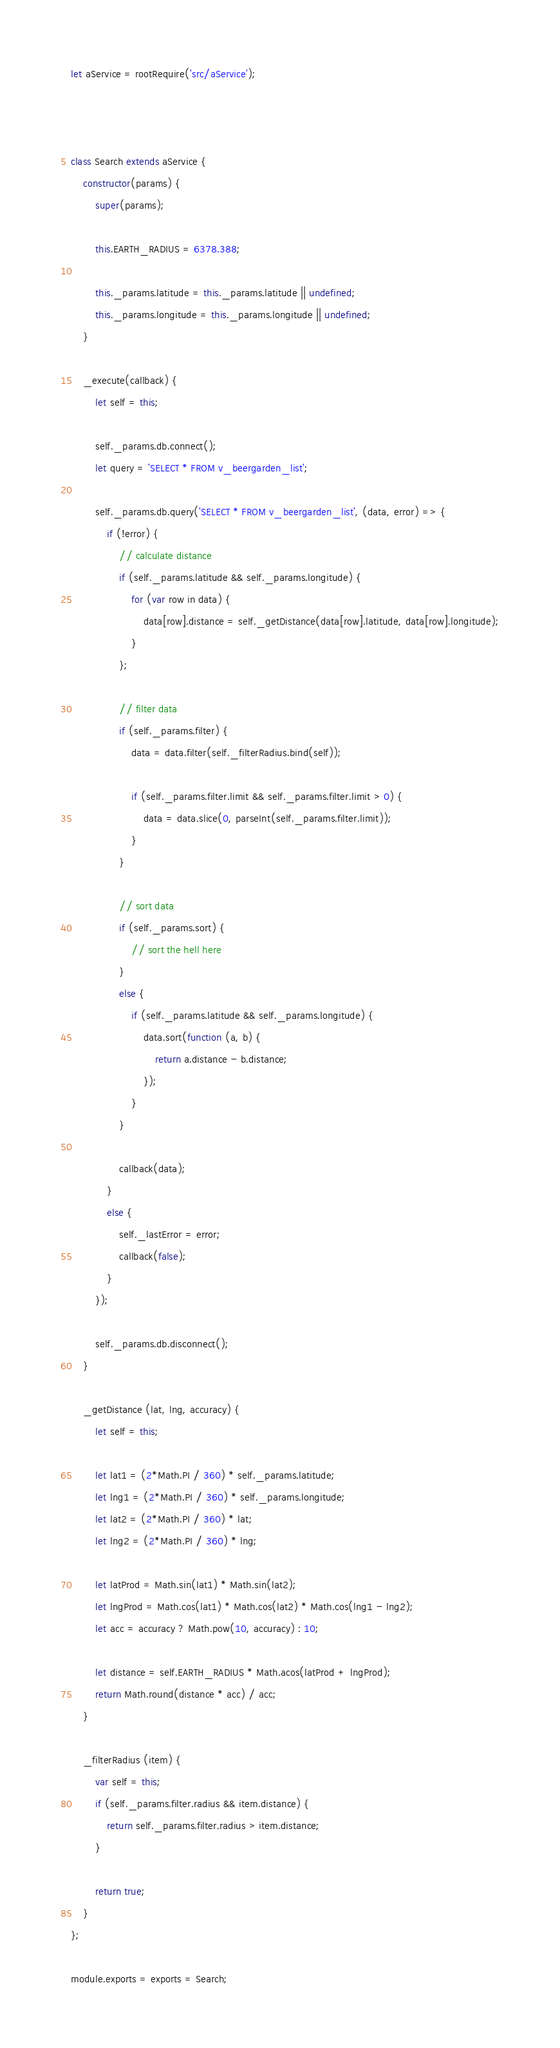Convert code to text. <code><loc_0><loc_0><loc_500><loc_500><_JavaScript_>let aService = rootRequire('src/aService');



class Search extends aService {
    constructor(params) {
        super(params);

        this.EARTH_RADIUS = 6378.388;

        this._params.latitude = this._params.latitude || undefined;
        this._params.longitude = this._params.longitude || undefined;
    }

    _execute(callback) {
        let self = this;

        self._params.db.connect();
        let query = 'SELECT * FROM v_beergarden_list';

        self._params.db.query('SELECT * FROM v_beergarden_list', (data, error) => {
            if (!error) {
                // calculate distance
                if (self._params.latitude && self._params.longitude) {
                    for (var row in data) {
                        data[row].distance = self._getDistance(data[row].latitude, data[row].longitude);
                    }
                };

                // filter data
                if (self._params.filter) {
                    data = data.filter(self._filterRadius.bind(self));

                    if (self._params.filter.limit && self._params.filter.limit > 0) {
                        data = data.slice(0, parseInt(self._params.filter.limit));
                    }
                }

                // sort data
                if (self._params.sort) {
                    // sort the hell here
                }
                else {
                    if (self._params.latitude && self._params.longitude) {
                        data.sort(function (a, b) {
                            return a.distance - b.distance;
                        });
                    }
                }

                callback(data);
            }
            else {
                self._lastError = error;
                callback(false);
            }
        });

        self._params.db.disconnect();
    }

    _getDistance (lat, lng, accuracy) {
        let self = this;

        let lat1 = (2*Math.PI / 360) * self._params.latitude;
        let lng1 = (2*Math.PI / 360) * self._params.longitude;
        let lat2 = (2*Math.PI / 360) * lat;
        let lng2 = (2*Math.PI / 360) * lng;

        let latProd = Math.sin(lat1) * Math.sin(lat2);
        let lngProd = Math.cos(lat1) * Math.cos(lat2) * Math.cos(lng1 - lng2);
        let acc = accuracy ? Math.pow(10, accuracy) : 10;

        let distance = self.EARTH_RADIUS * Math.acos(latProd + lngProd);
        return Math.round(distance * acc) / acc;
    }

    _filterRadius (item) {
        var self = this;
        if (self._params.filter.radius && item.distance) {
            return self._params.filter.radius > item.distance;
        }

        return true;
    }
};

module.exports = exports = Search;</code> 